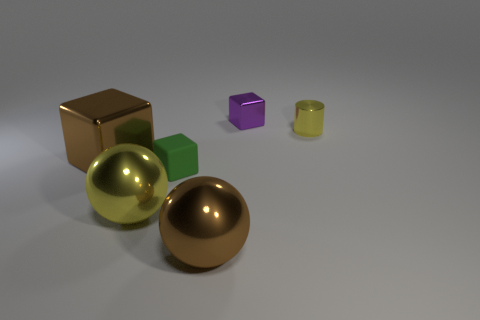Are there any other tiny objects of the same shape as the tiny green thing? Yes, there is a tiny purple cube that shares the same shape as the tiny green cube. 